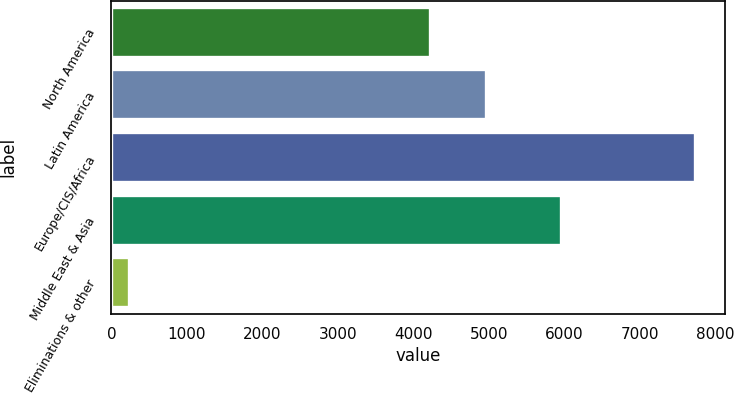Convert chart. <chart><loc_0><loc_0><loc_500><loc_500><bar_chart><fcel>North America<fcel>Latin America<fcel>Europe/CIS/Africa<fcel>Middle East & Asia<fcel>Eliminations & other<nl><fcel>4217<fcel>4967.2<fcel>7737<fcel>5961<fcel>235<nl></chart> 